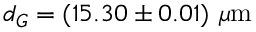Convert formula to latex. <formula><loc_0><loc_0><loc_500><loc_500>d _ { G } = ( 1 5 . 3 0 \pm 0 . 0 1 ) \mu m</formula> 